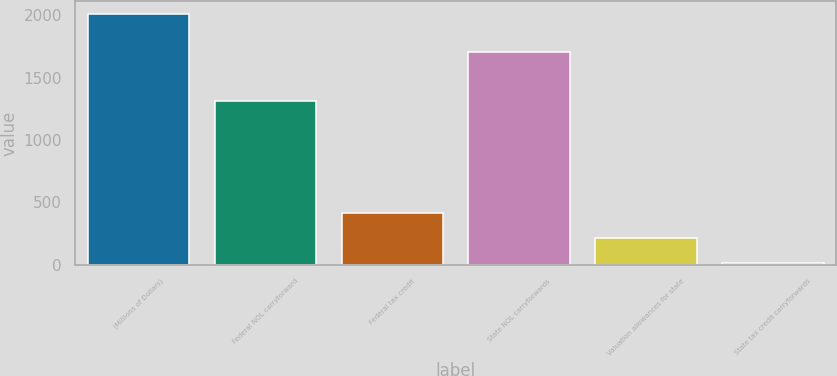Convert chart to OTSL. <chart><loc_0><loc_0><loc_500><loc_500><bar_chart><fcel>(Millions of Dollars)<fcel>Federal NOL carryforward<fcel>Federal tax credit<fcel>State NOL carryforwards<fcel>Valuation allowances for state<fcel>State tax credit carryforwards<nl><fcel>2013<fcel>1311<fcel>416.2<fcel>1706<fcel>216.6<fcel>17<nl></chart> 